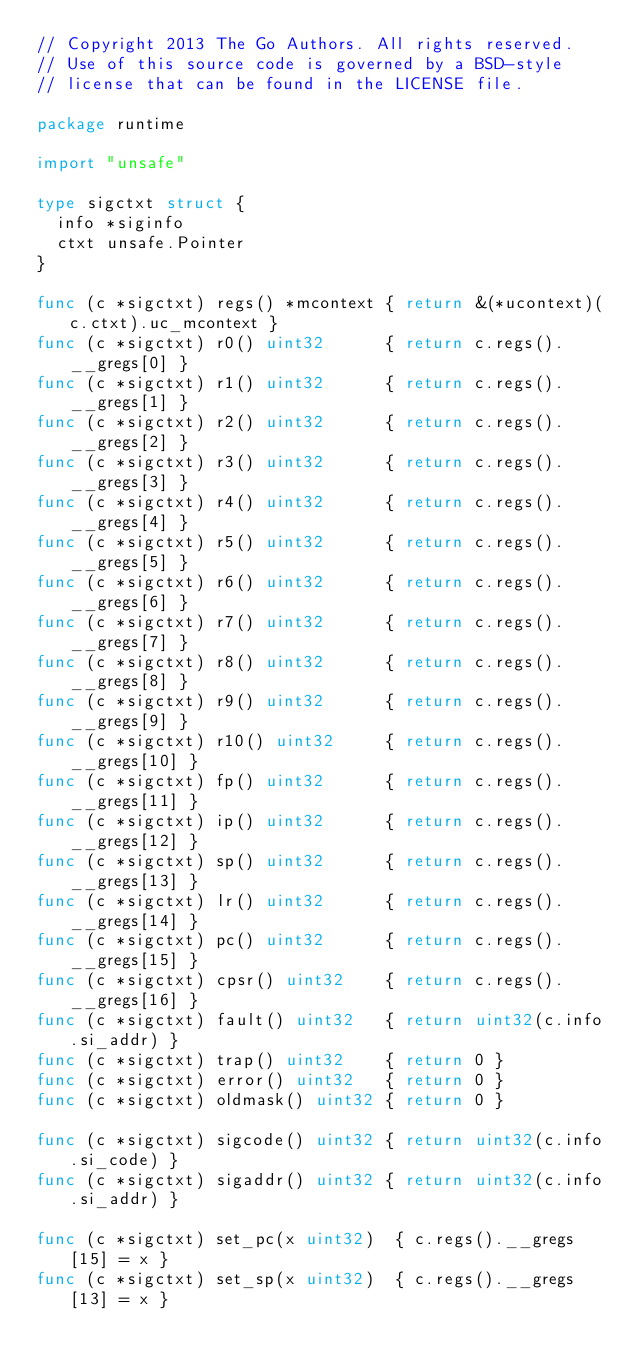Convert code to text. <code><loc_0><loc_0><loc_500><loc_500><_Go_>// Copyright 2013 The Go Authors. All rights reserved.
// Use of this source code is governed by a BSD-style
// license that can be found in the LICENSE file.

package runtime

import "unsafe"

type sigctxt struct {
	info *siginfo
	ctxt unsafe.Pointer
}

func (c *sigctxt) regs() *mcontext { return &(*ucontext)(c.ctxt).uc_mcontext }
func (c *sigctxt) r0() uint32      { return c.regs().__gregs[0] }
func (c *sigctxt) r1() uint32      { return c.regs().__gregs[1] }
func (c *sigctxt) r2() uint32      { return c.regs().__gregs[2] }
func (c *sigctxt) r3() uint32      { return c.regs().__gregs[3] }
func (c *sigctxt) r4() uint32      { return c.regs().__gregs[4] }
func (c *sigctxt) r5() uint32      { return c.regs().__gregs[5] }
func (c *sigctxt) r6() uint32      { return c.regs().__gregs[6] }
func (c *sigctxt) r7() uint32      { return c.regs().__gregs[7] }
func (c *sigctxt) r8() uint32      { return c.regs().__gregs[8] }
func (c *sigctxt) r9() uint32      { return c.regs().__gregs[9] }
func (c *sigctxt) r10() uint32     { return c.regs().__gregs[10] }
func (c *sigctxt) fp() uint32      { return c.regs().__gregs[11] }
func (c *sigctxt) ip() uint32      { return c.regs().__gregs[12] }
func (c *sigctxt) sp() uint32      { return c.regs().__gregs[13] }
func (c *sigctxt) lr() uint32      { return c.regs().__gregs[14] }
func (c *sigctxt) pc() uint32      { return c.regs().__gregs[15] }
func (c *sigctxt) cpsr() uint32    { return c.regs().__gregs[16] }
func (c *sigctxt) fault() uint32   { return uint32(c.info.si_addr) }
func (c *sigctxt) trap() uint32    { return 0 }
func (c *sigctxt) error() uint32   { return 0 }
func (c *sigctxt) oldmask() uint32 { return 0 }

func (c *sigctxt) sigcode() uint32 { return uint32(c.info.si_code) }
func (c *sigctxt) sigaddr() uint32 { return uint32(c.info.si_addr) }

func (c *sigctxt) set_pc(x uint32)  { c.regs().__gregs[15] = x }
func (c *sigctxt) set_sp(x uint32)  { c.regs().__gregs[13] = x }</code> 